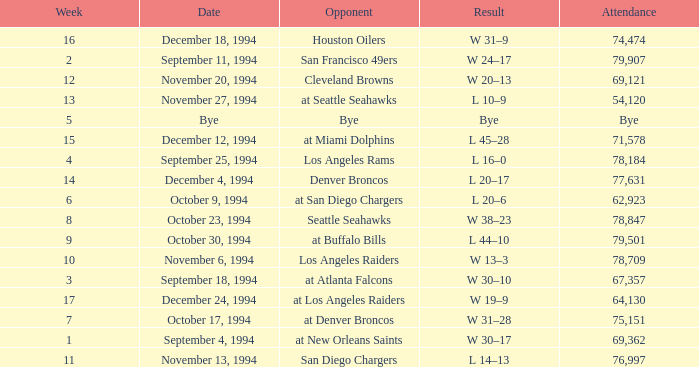What was the score of the Chiefs pre-Week 16 game that 69,362 people attended? W 30–17. 